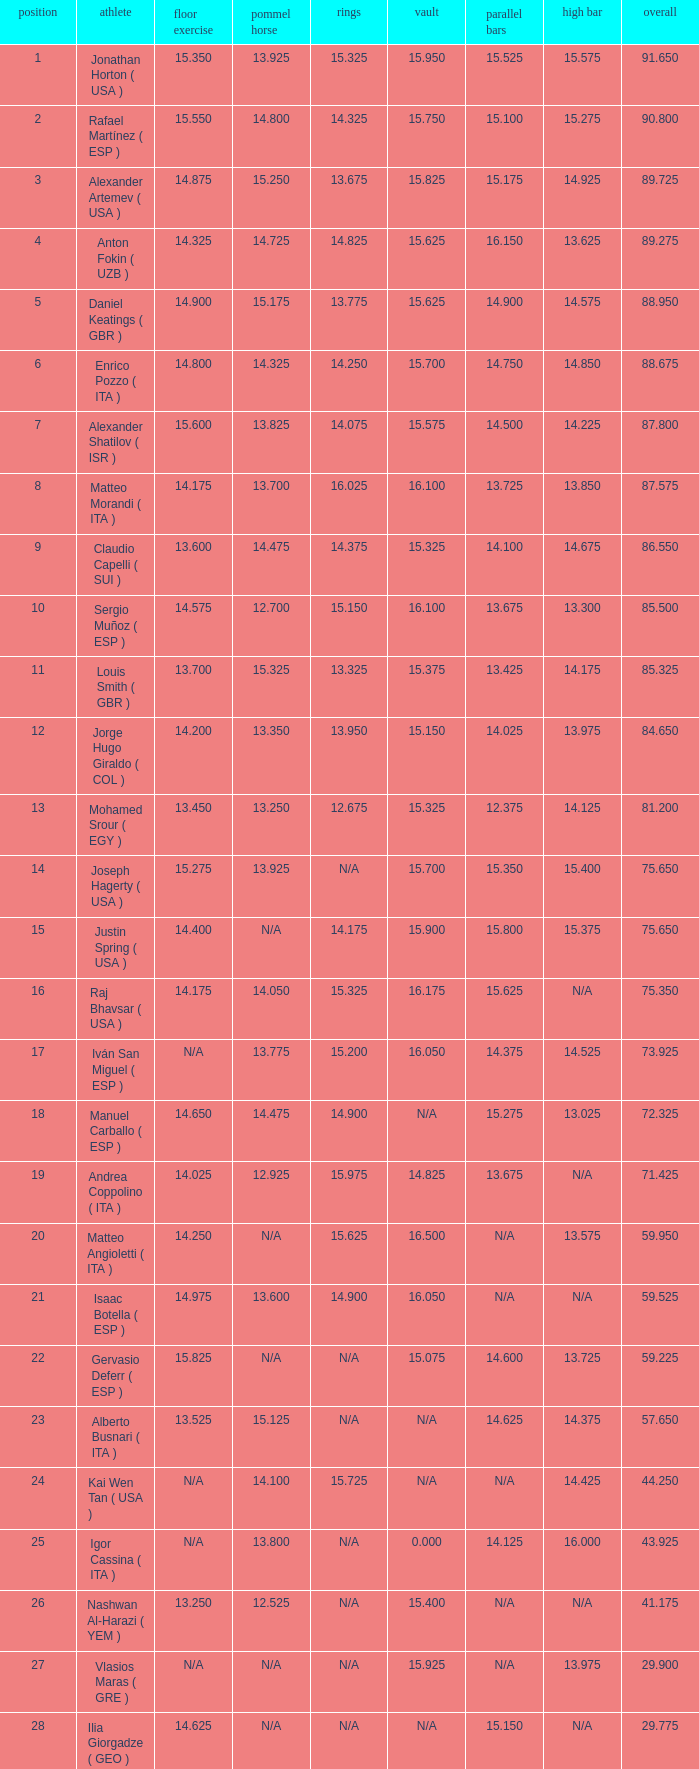If the parallel bars score is 1 Anton Fokin ( UZB ). 